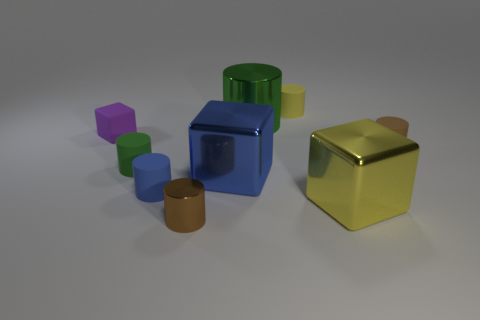What number of things are either green matte cylinders or brown cylinders?
Ensure brevity in your answer.  3. What shape is the green thing that is made of the same material as the yellow block?
Give a very brief answer. Cylinder. What number of big objects are either blue metal cylinders or yellow matte objects?
Your response must be concise. 0. What number of other things are there of the same color as the big metal cylinder?
Give a very brief answer. 1. There is a small rubber cylinder that is to the left of the tiny matte cylinder in front of the small green matte cylinder; what number of yellow objects are behind it?
Ensure brevity in your answer.  1. There is a blue object that is behind the blue matte cylinder; does it have the same size as the yellow rubber object?
Keep it short and to the point. No. Are there fewer tiny blue cylinders to the right of the yellow cylinder than tiny brown metallic cylinders that are in front of the yellow metal cube?
Keep it short and to the point. Yes. Is the number of matte cylinders that are behind the purple cube less than the number of small blue cylinders?
Ensure brevity in your answer.  No. There is a thing that is the same color as the large metallic cylinder; what material is it?
Your answer should be very brief. Rubber. Is the material of the small green cylinder the same as the tiny block?
Your response must be concise. Yes. 